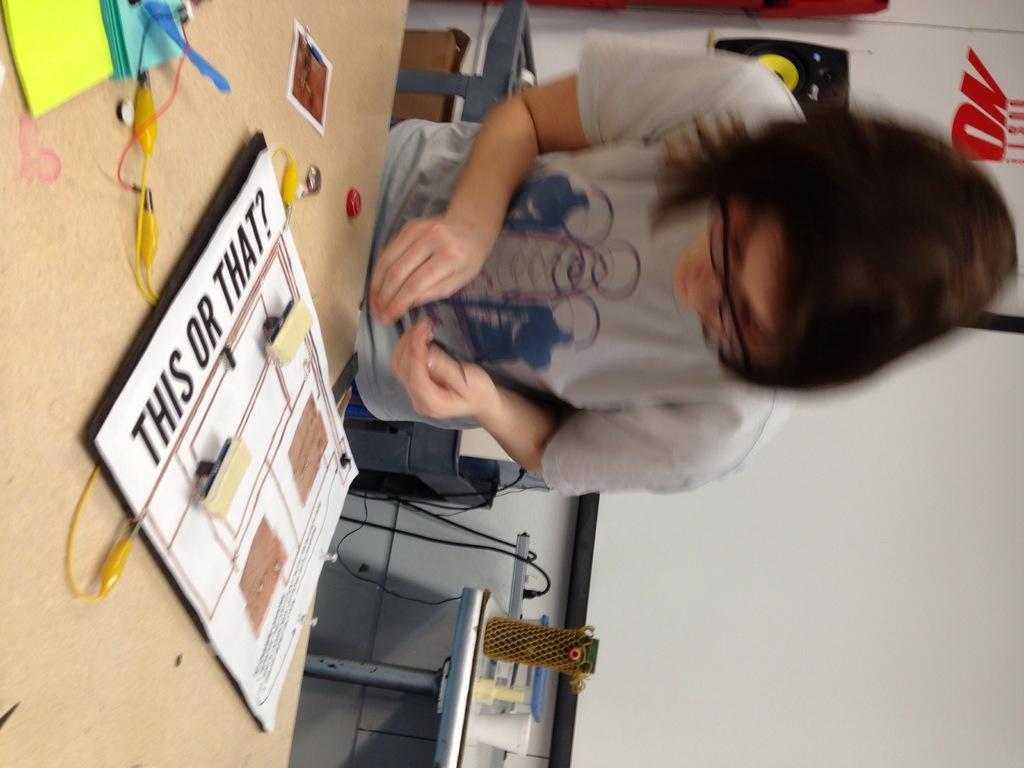How would you summarize this image in a sentence or two? Here in this picture we can see a woman standing over a place and in front of her we can see a table present on which we can see a cardboard with something present on it over there and we can see other cable wires and papers present on it over there and we can see she is wearing spectacles on her and behind her also we can see some things present on the table over there and we can also see wires and extension present and on the wall we can see posters present and we can see a projector screen present on the wall over there. 